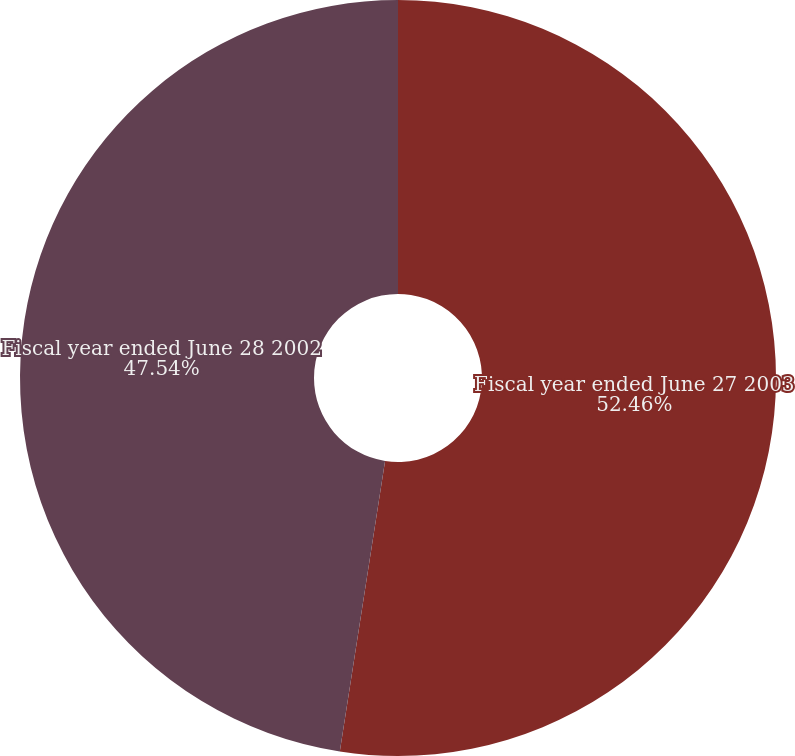Convert chart to OTSL. <chart><loc_0><loc_0><loc_500><loc_500><pie_chart><fcel>Fiscal year ended June 27 2003<fcel>Fiscal year ended June 28 2002<nl><fcel>52.46%<fcel>47.54%<nl></chart> 